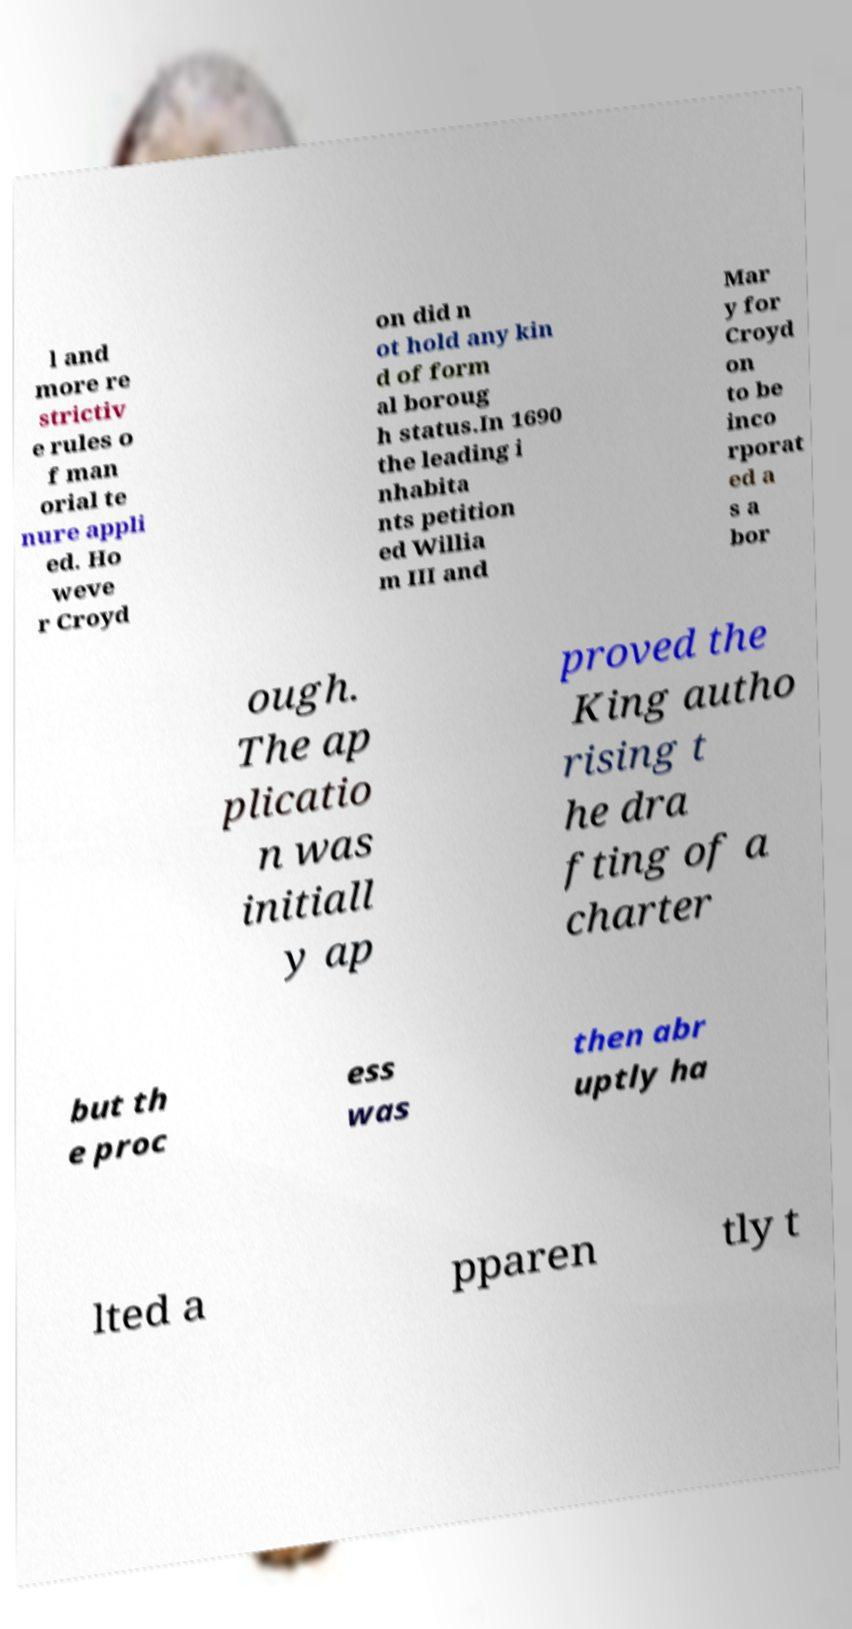Can you read and provide the text displayed in the image?This photo seems to have some interesting text. Can you extract and type it out for me? l and more re strictiv e rules o f man orial te nure appli ed. Ho weve r Croyd on did n ot hold any kin d of form al boroug h status.In 1690 the leading i nhabita nts petition ed Willia m III and Mar y for Croyd on to be inco rporat ed a s a bor ough. The ap plicatio n was initiall y ap proved the King autho rising t he dra fting of a charter but th e proc ess was then abr uptly ha lted a pparen tly t 